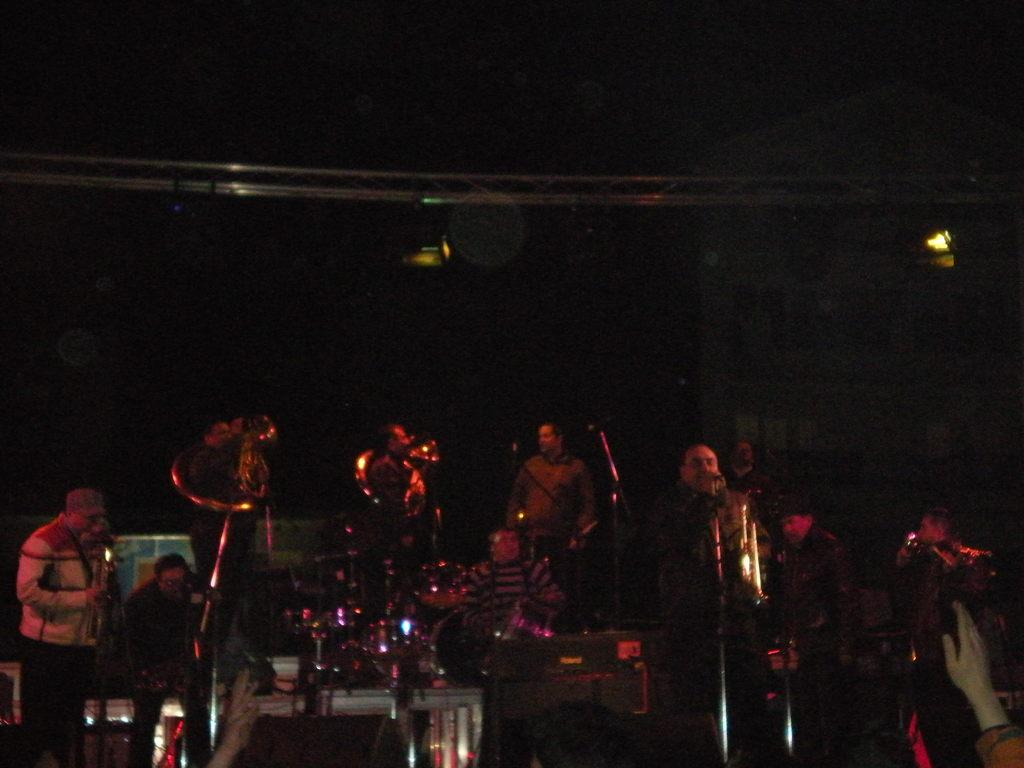How many people are in the image? There are people in the image, but the exact number is not specified. What are the people doing in the image? Most of the people are holding musical instruments. What type of plate is being used to control the behavior of the people in the image? There is no plate present in the image, and the behavior of the people is not mentioned. 